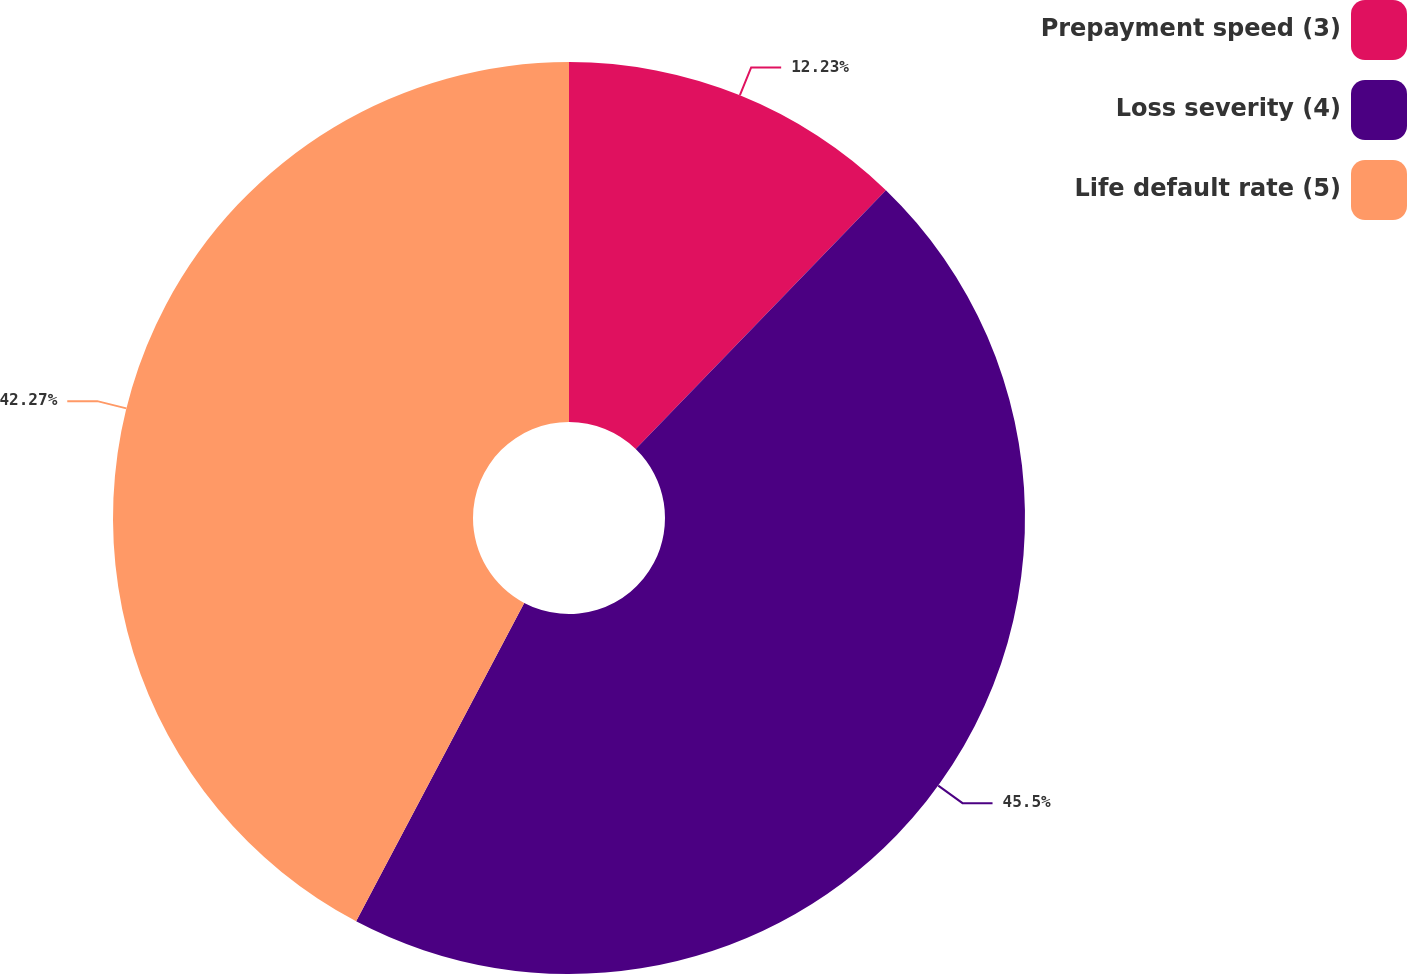<chart> <loc_0><loc_0><loc_500><loc_500><pie_chart><fcel>Prepayment speed (3)<fcel>Loss severity (4)<fcel>Life default rate (5)<nl><fcel>12.23%<fcel>45.5%<fcel>42.27%<nl></chart> 